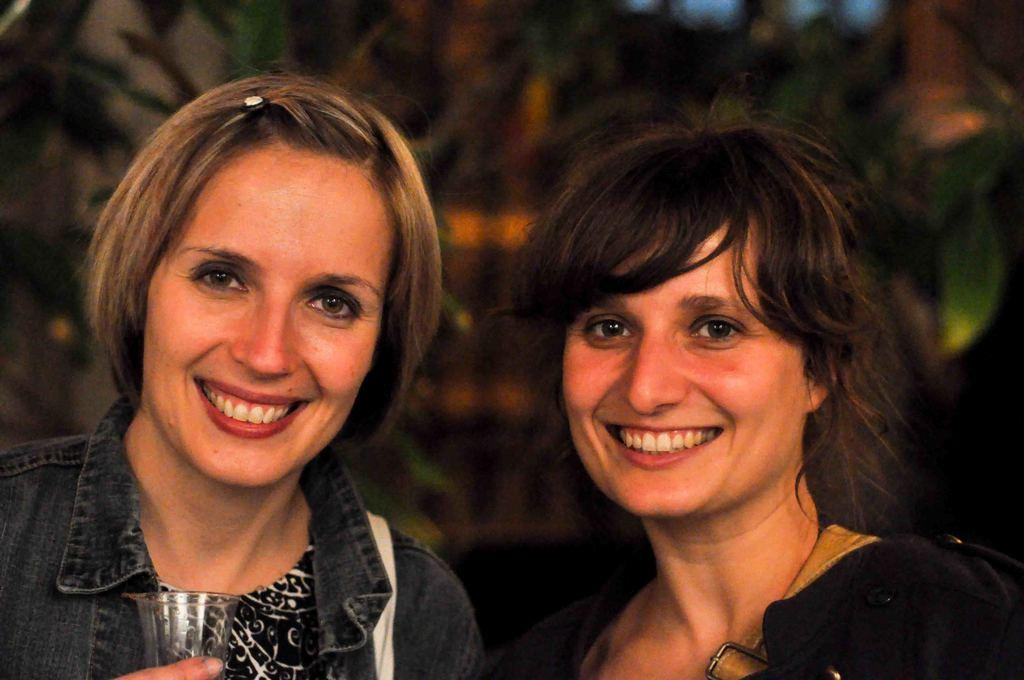How many people are present in the image? There are two women in the image. What type of card can be seen being used by one of the women in the image? There is no card present in the image; it only features two women. 